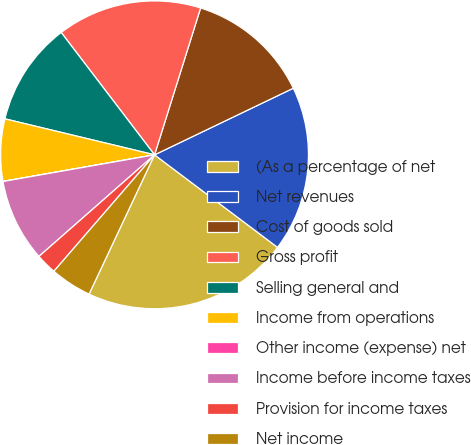Convert chart. <chart><loc_0><loc_0><loc_500><loc_500><pie_chart><fcel>(As a percentage of net<fcel>Net revenues<fcel>Cost of goods sold<fcel>Gross profit<fcel>Selling general and<fcel>Income from operations<fcel>Other income (expense) net<fcel>Income before income taxes<fcel>Provision for income taxes<fcel>Net income<nl><fcel>21.73%<fcel>17.39%<fcel>13.04%<fcel>15.21%<fcel>10.87%<fcel>6.52%<fcel>0.01%<fcel>8.7%<fcel>2.18%<fcel>4.35%<nl></chart> 